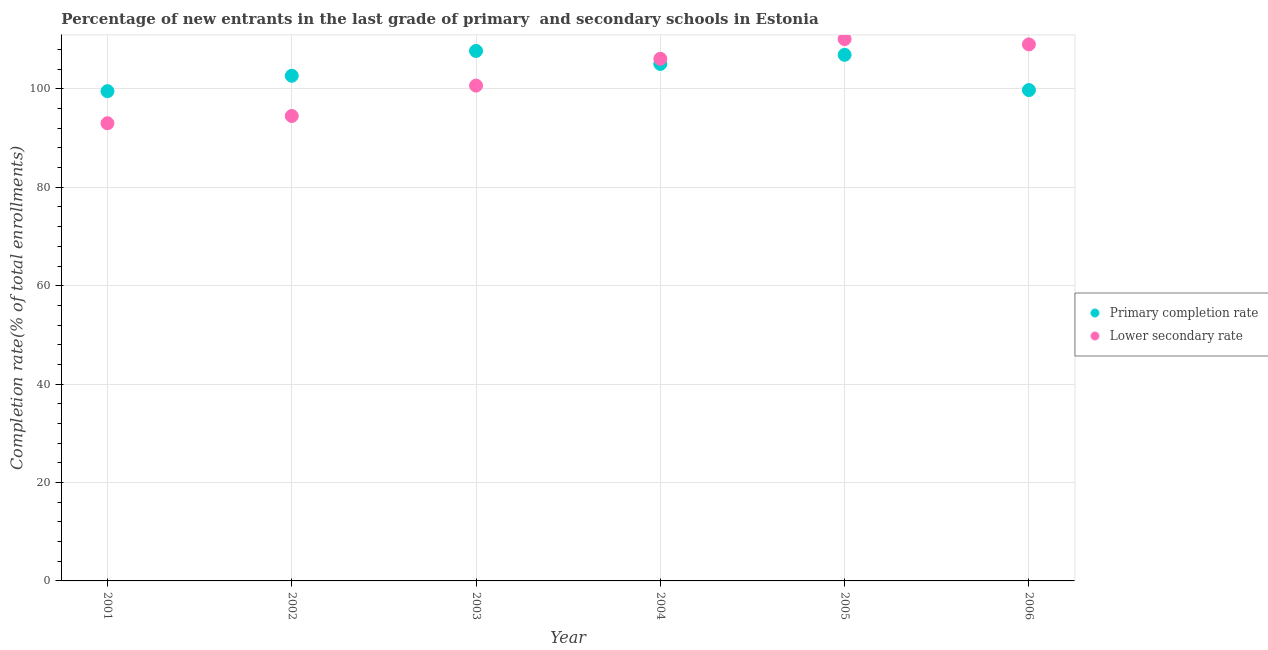How many different coloured dotlines are there?
Give a very brief answer. 2. Is the number of dotlines equal to the number of legend labels?
Your answer should be compact. Yes. What is the completion rate in secondary schools in 2002?
Your answer should be very brief. 94.5. Across all years, what is the maximum completion rate in secondary schools?
Provide a succinct answer. 110.13. Across all years, what is the minimum completion rate in secondary schools?
Keep it short and to the point. 93.02. What is the total completion rate in secondary schools in the graph?
Give a very brief answer. 613.49. What is the difference between the completion rate in primary schools in 2003 and that in 2005?
Give a very brief answer. 0.79. What is the difference between the completion rate in primary schools in 2003 and the completion rate in secondary schools in 2004?
Offer a terse response. 1.59. What is the average completion rate in primary schools per year?
Your answer should be compact. 103.62. In the year 2002, what is the difference between the completion rate in primary schools and completion rate in secondary schools?
Your answer should be compact. 8.18. What is the ratio of the completion rate in primary schools in 2004 to that in 2005?
Offer a terse response. 0.98. Is the difference between the completion rate in secondary schools in 2002 and 2003 greater than the difference between the completion rate in primary schools in 2002 and 2003?
Offer a terse response. No. What is the difference between the highest and the second highest completion rate in secondary schools?
Offer a terse response. 1.08. What is the difference between the highest and the lowest completion rate in primary schools?
Offer a terse response. 8.18. In how many years, is the completion rate in secondary schools greater than the average completion rate in secondary schools taken over all years?
Your answer should be very brief. 3. What is the difference between two consecutive major ticks on the Y-axis?
Ensure brevity in your answer.  20. Does the graph contain any zero values?
Ensure brevity in your answer.  No. How are the legend labels stacked?
Make the answer very short. Vertical. What is the title of the graph?
Your answer should be very brief. Percentage of new entrants in the last grade of primary  and secondary schools in Estonia. What is the label or title of the Y-axis?
Give a very brief answer. Completion rate(% of total enrollments). What is the Completion rate(% of total enrollments) in Primary completion rate in 2001?
Offer a terse response. 99.54. What is the Completion rate(% of total enrollments) of Lower secondary rate in 2001?
Ensure brevity in your answer.  93.02. What is the Completion rate(% of total enrollments) of Primary completion rate in 2002?
Give a very brief answer. 102.67. What is the Completion rate(% of total enrollments) of Lower secondary rate in 2002?
Make the answer very short. 94.5. What is the Completion rate(% of total enrollments) of Primary completion rate in 2003?
Keep it short and to the point. 107.72. What is the Completion rate(% of total enrollments) in Lower secondary rate in 2003?
Ensure brevity in your answer.  100.67. What is the Completion rate(% of total enrollments) of Primary completion rate in 2004?
Ensure brevity in your answer.  105.08. What is the Completion rate(% of total enrollments) of Lower secondary rate in 2004?
Keep it short and to the point. 106.13. What is the Completion rate(% of total enrollments) in Primary completion rate in 2005?
Give a very brief answer. 106.93. What is the Completion rate(% of total enrollments) of Lower secondary rate in 2005?
Your response must be concise. 110.13. What is the Completion rate(% of total enrollments) in Primary completion rate in 2006?
Your answer should be compact. 99.77. What is the Completion rate(% of total enrollments) of Lower secondary rate in 2006?
Offer a very short reply. 109.04. Across all years, what is the maximum Completion rate(% of total enrollments) in Primary completion rate?
Keep it short and to the point. 107.72. Across all years, what is the maximum Completion rate(% of total enrollments) of Lower secondary rate?
Your answer should be compact. 110.13. Across all years, what is the minimum Completion rate(% of total enrollments) of Primary completion rate?
Make the answer very short. 99.54. Across all years, what is the minimum Completion rate(% of total enrollments) in Lower secondary rate?
Offer a very short reply. 93.02. What is the total Completion rate(% of total enrollments) in Primary completion rate in the graph?
Your answer should be compact. 621.71. What is the total Completion rate(% of total enrollments) of Lower secondary rate in the graph?
Ensure brevity in your answer.  613.49. What is the difference between the Completion rate(% of total enrollments) of Primary completion rate in 2001 and that in 2002?
Provide a short and direct response. -3.13. What is the difference between the Completion rate(% of total enrollments) in Lower secondary rate in 2001 and that in 2002?
Your answer should be compact. -1.48. What is the difference between the Completion rate(% of total enrollments) of Primary completion rate in 2001 and that in 2003?
Provide a short and direct response. -8.18. What is the difference between the Completion rate(% of total enrollments) of Lower secondary rate in 2001 and that in 2003?
Make the answer very short. -7.65. What is the difference between the Completion rate(% of total enrollments) in Primary completion rate in 2001 and that in 2004?
Offer a very short reply. -5.54. What is the difference between the Completion rate(% of total enrollments) of Lower secondary rate in 2001 and that in 2004?
Your answer should be compact. -13.11. What is the difference between the Completion rate(% of total enrollments) of Primary completion rate in 2001 and that in 2005?
Your response must be concise. -7.38. What is the difference between the Completion rate(% of total enrollments) in Lower secondary rate in 2001 and that in 2005?
Your answer should be very brief. -17.11. What is the difference between the Completion rate(% of total enrollments) of Primary completion rate in 2001 and that in 2006?
Keep it short and to the point. -0.22. What is the difference between the Completion rate(% of total enrollments) of Lower secondary rate in 2001 and that in 2006?
Provide a short and direct response. -16.02. What is the difference between the Completion rate(% of total enrollments) of Primary completion rate in 2002 and that in 2003?
Provide a short and direct response. -5.05. What is the difference between the Completion rate(% of total enrollments) in Lower secondary rate in 2002 and that in 2003?
Ensure brevity in your answer.  -6.18. What is the difference between the Completion rate(% of total enrollments) of Primary completion rate in 2002 and that in 2004?
Ensure brevity in your answer.  -2.41. What is the difference between the Completion rate(% of total enrollments) in Lower secondary rate in 2002 and that in 2004?
Your response must be concise. -11.63. What is the difference between the Completion rate(% of total enrollments) of Primary completion rate in 2002 and that in 2005?
Give a very brief answer. -4.26. What is the difference between the Completion rate(% of total enrollments) of Lower secondary rate in 2002 and that in 2005?
Provide a short and direct response. -15.63. What is the difference between the Completion rate(% of total enrollments) of Primary completion rate in 2002 and that in 2006?
Offer a terse response. 2.91. What is the difference between the Completion rate(% of total enrollments) in Lower secondary rate in 2002 and that in 2006?
Ensure brevity in your answer.  -14.55. What is the difference between the Completion rate(% of total enrollments) of Primary completion rate in 2003 and that in 2004?
Keep it short and to the point. 2.64. What is the difference between the Completion rate(% of total enrollments) in Lower secondary rate in 2003 and that in 2004?
Provide a succinct answer. -5.45. What is the difference between the Completion rate(% of total enrollments) of Primary completion rate in 2003 and that in 2005?
Give a very brief answer. 0.79. What is the difference between the Completion rate(% of total enrollments) in Lower secondary rate in 2003 and that in 2005?
Offer a very short reply. -9.46. What is the difference between the Completion rate(% of total enrollments) of Primary completion rate in 2003 and that in 2006?
Ensure brevity in your answer.  7.96. What is the difference between the Completion rate(% of total enrollments) of Lower secondary rate in 2003 and that in 2006?
Give a very brief answer. -8.37. What is the difference between the Completion rate(% of total enrollments) in Primary completion rate in 2004 and that in 2005?
Your answer should be compact. -1.85. What is the difference between the Completion rate(% of total enrollments) of Lower secondary rate in 2004 and that in 2005?
Your answer should be very brief. -4. What is the difference between the Completion rate(% of total enrollments) in Primary completion rate in 2004 and that in 2006?
Offer a very short reply. 5.32. What is the difference between the Completion rate(% of total enrollments) in Lower secondary rate in 2004 and that in 2006?
Make the answer very short. -2.92. What is the difference between the Completion rate(% of total enrollments) of Primary completion rate in 2005 and that in 2006?
Give a very brief answer. 7.16. What is the difference between the Completion rate(% of total enrollments) of Lower secondary rate in 2005 and that in 2006?
Ensure brevity in your answer.  1.08. What is the difference between the Completion rate(% of total enrollments) of Primary completion rate in 2001 and the Completion rate(% of total enrollments) of Lower secondary rate in 2002?
Provide a short and direct response. 5.05. What is the difference between the Completion rate(% of total enrollments) of Primary completion rate in 2001 and the Completion rate(% of total enrollments) of Lower secondary rate in 2003?
Offer a terse response. -1.13. What is the difference between the Completion rate(% of total enrollments) in Primary completion rate in 2001 and the Completion rate(% of total enrollments) in Lower secondary rate in 2004?
Offer a terse response. -6.58. What is the difference between the Completion rate(% of total enrollments) of Primary completion rate in 2001 and the Completion rate(% of total enrollments) of Lower secondary rate in 2005?
Offer a very short reply. -10.58. What is the difference between the Completion rate(% of total enrollments) of Primary completion rate in 2001 and the Completion rate(% of total enrollments) of Lower secondary rate in 2006?
Make the answer very short. -9.5. What is the difference between the Completion rate(% of total enrollments) in Primary completion rate in 2002 and the Completion rate(% of total enrollments) in Lower secondary rate in 2003?
Provide a succinct answer. 2. What is the difference between the Completion rate(% of total enrollments) in Primary completion rate in 2002 and the Completion rate(% of total enrollments) in Lower secondary rate in 2004?
Provide a short and direct response. -3.45. What is the difference between the Completion rate(% of total enrollments) in Primary completion rate in 2002 and the Completion rate(% of total enrollments) in Lower secondary rate in 2005?
Provide a short and direct response. -7.46. What is the difference between the Completion rate(% of total enrollments) in Primary completion rate in 2002 and the Completion rate(% of total enrollments) in Lower secondary rate in 2006?
Provide a short and direct response. -6.37. What is the difference between the Completion rate(% of total enrollments) of Primary completion rate in 2003 and the Completion rate(% of total enrollments) of Lower secondary rate in 2004?
Ensure brevity in your answer.  1.59. What is the difference between the Completion rate(% of total enrollments) of Primary completion rate in 2003 and the Completion rate(% of total enrollments) of Lower secondary rate in 2005?
Give a very brief answer. -2.41. What is the difference between the Completion rate(% of total enrollments) in Primary completion rate in 2003 and the Completion rate(% of total enrollments) in Lower secondary rate in 2006?
Your answer should be very brief. -1.32. What is the difference between the Completion rate(% of total enrollments) in Primary completion rate in 2004 and the Completion rate(% of total enrollments) in Lower secondary rate in 2005?
Give a very brief answer. -5.05. What is the difference between the Completion rate(% of total enrollments) in Primary completion rate in 2004 and the Completion rate(% of total enrollments) in Lower secondary rate in 2006?
Offer a very short reply. -3.96. What is the difference between the Completion rate(% of total enrollments) of Primary completion rate in 2005 and the Completion rate(% of total enrollments) of Lower secondary rate in 2006?
Give a very brief answer. -2.12. What is the average Completion rate(% of total enrollments) of Primary completion rate per year?
Make the answer very short. 103.62. What is the average Completion rate(% of total enrollments) of Lower secondary rate per year?
Offer a very short reply. 102.25. In the year 2001, what is the difference between the Completion rate(% of total enrollments) of Primary completion rate and Completion rate(% of total enrollments) of Lower secondary rate?
Provide a short and direct response. 6.52. In the year 2002, what is the difference between the Completion rate(% of total enrollments) in Primary completion rate and Completion rate(% of total enrollments) in Lower secondary rate?
Your answer should be compact. 8.18. In the year 2003, what is the difference between the Completion rate(% of total enrollments) of Primary completion rate and Completion rate(% of total enrollments) of Lower secondary rate?
Give a very brief answer. 7.05. In the year 2004, what is the difference between the Completion rate(% of total enrollments) in Primary completion rate and Completion rate(% of total enrollments) in Lower secondary rate?
Your response must be concise. -1.05. In the year 2005, what is the difference between the Completion rate(% of total enrollments) of Primary completion rate and Completion rate(% of total enrollments) of Lower secondary rate?
Offer a very short reply. -3.2. In the year 2006, what is the difference between the Completion rate(% of total enrollments) in Primary completion rate and Completion rate(% of total enrollments) in Lower secondary rate?
Your response must be concise. -9.28. What is the ratio of the Completion rate(% of total enrollments) in Primary completion rate in 2001 to that in 2002?
Provide a succinct answer. 0.97. What is the ratio of the Completion rate(% of total enrollments) of Lower secondary rate in 2001 to that in 2002?
Provide a short and direct response. 0.98. What is the ratio of the Completion rate(% of total enrollments) of Primary completion rate in 2001 to that in 2003?
Ensure brevity in your answer.  0.92. What is the ratio of the Completion rate(% of total enrollments) in Lower secondary rate in 2001 to that in 2003?
Keep it short and to the point. 0.92. What is the ratio of the Completion rate(% of total enrollments) of Primary completion rate in 2001 to that in 2004?
Give a very brief answer. 0.95. What is the ratio of the Completion rate(% of total enrollments) in Lower secondary rate in 2001 to that in 2004?
Your answer should be compact. 0.88. What is the ratio of the Completion rate(% of total enrollments) of Primary completion rate in 2001 to that in 2005?
Give a very brief answer. 0.93. What is the ratio of the Completion rate(% of total enrollments) of Lower secondary rate in 2001 to that in 2005?
Make the answer very short. 0.84. What is the ratio of the Completion rate(% of total enrollments) in Lower secondary rate in 2001 to that in 2006?
Keep it short and to the point. 0.85. What is the ratio of the Completion rate(% of total enrollments) in Primary completion rate in 2002 to that in 2003?
Keep it short and to the point. 0.95. What is the ratio of the Completion rate(% of total enrollments) of Lower secondary rate in 2002 to that in 2003?
Keep it short and to the point. 0.94. What is the ratio of the Completion rate(% of total enrollments) in Primary completion rate in 2002 to that in 2004?
Provide a succinct answer. 0.98. What is the ratio of the Completion rate(% of total enrollments) of Lower secondary rate in 2002 to that in 2004?
Keep it short and to the point. 0.89. What is the ratio of the Completion rate(% of total enrollments) in Primary completion rate in 2002 to that in 2005?
Offer a terse response. 0.96. What is the ratio of the Completion rate(% of total enrollments) of Lower secondary rate in 2002 to that in 2005?
Provide a short and direct response. 0.86. What is the ratio of the Completion rate(% of total enrollments) in Primary completion rate in 2002 to that in 2006?
Your answer should be very brief. 1.03. What is the ratio of the Completion rate(% of total enrollments) of Lower secondary rate in 2002 to that in 2006?
Make the answer very short. 0.87. What is the ratio of the Completion rate(% of total enrollments) of Primary completion rate in 2003 to that in 2004?
Your answer should be compact. 1.03. What is the ratio of the Completion rate(% of total enrollments) of Lower secondary rate in 2003 to that in 2004?
Give a very brief answer. 0.95. What is the ratio of the Completion rate(% of total enrollments) of Primary completion rate in 2003 to that in 2005?
Keep it short and to the point. 1.01. What is the ratio of the Completion rate(% of total enrollments) in Lower secondary rate in 2003 to that in 2005?
Make the answer very short. 0.91. What is the ratio of the Completion rate(% of total enrollments) of Primary completion rate in 2003 to that in 2006?
Offer a terse response. 1.08. What is the ratio of the Completion rate(% of total enrollments) in Lower secondary rate in 2003 to that in 2006?
Your answer should be compact. 0.92. What is the ratio of the Completion rate(% of total enrollments) of Primary completion rate in 2004 to that in 2005?
Provide a succinct answer. 0.98. What is the ratio of the Completion rate(% of total enrollments) in Lower secondary rate in 2004 to that in 2005?
Your response must be concise. 0.96. What is the ratio of the Completion rate(% of total enrollments) in Primary completion rate in 2004 to that in 2006?
Make the answer very short. 1.05. What is the ratio of the Completion rate(% of total enrollments) in Lower secondary rate in 2004 to that in 2006?
Offer a terse response. 0.97. What is the ratio of the Completion rate(% of total enrollments) in Primary completion rate in 2005 to that in 2006?
Offer a terse response. 1.07. What is the ratio of the Completion rate(% of total enrollments) of Lower secondary rate in 2005 to that in 2006?
Provide a short and direct response. 1.01. What is the difference between the highest and the second highest Completion rate(% of total enrollments) of Primary completion rate?
Your response must be concise. 0.79. What is the difference between the highest and the second highest Completion rate(% of total enrollments) in Lower secondary rate?
Offer a very short reply. 1.08. What is the difference between the highest and the lowest Completion rate(% of total enrollments) of Primary completion rate?
Keep it short and to the point. 8.18. What is the difference between the highest and the lowest Completion rate(% of total enrollments) in Lower secondary rate?
Make the answer very short. 17.11. 